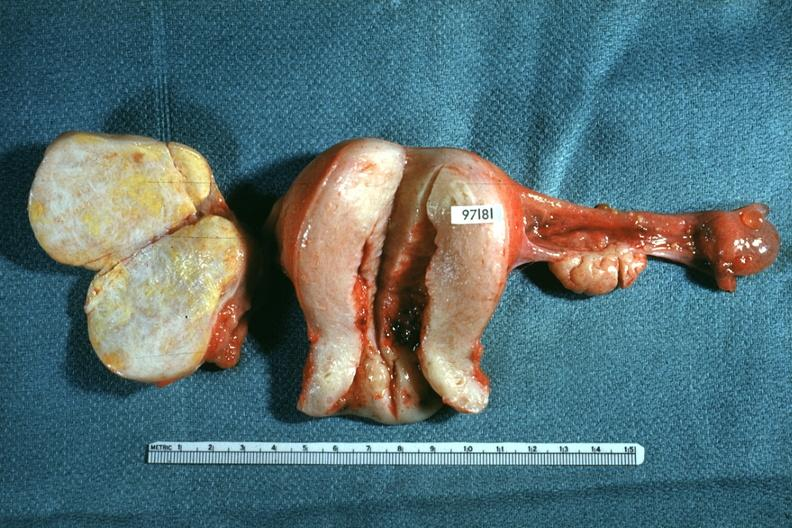does hemorrhagic corpus luteum show ovaries and uterus with tumor mass?
Answer the question using a single word or phrase. No 